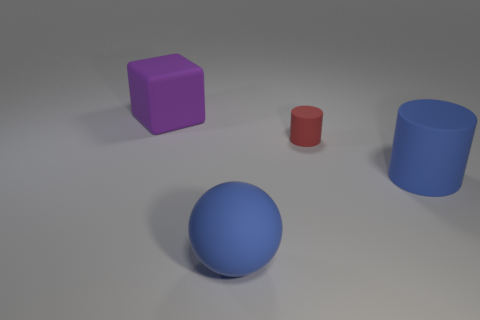Add 3 red cylinders. How many objects exist? 7 Subtract all spheres. How many objects are left? 3 Add 4 blue things. How many blue things exist? 6 Subtract 0 purple cylinders. How many objects are left? 4 Subtract all large purple things. Subtract all large rubber balls. How many objects are left? 2 Add 4 big cylinders. How many big cylinders are left? 5 